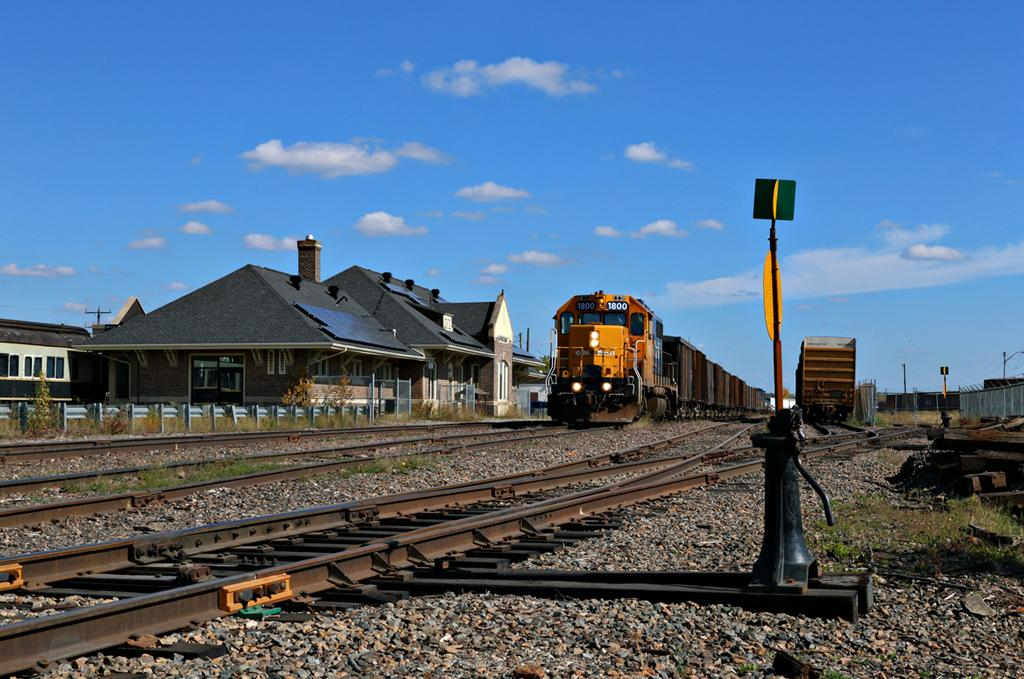What is moving along the tracks in the image? There are trains on the tracks in the image. What structures are located near the trains? There are buildings near the trains. What type of vertical structures can be seen in the image? There are poles in the image. What type of barrier is present in the image? There is a fence in the image. What type of natural elements are present in the image? Stones are present in the image. What can be seen in the sky in the image? Clouds are visible in the image. What type of house is the worm living in the image? There is no house or worm present in the image. How does the temper of the clouds affect the trains in the image? The temper of the clouds does not affect the trains in the image, as clouds are not sentient beings and cannot have a temper. 